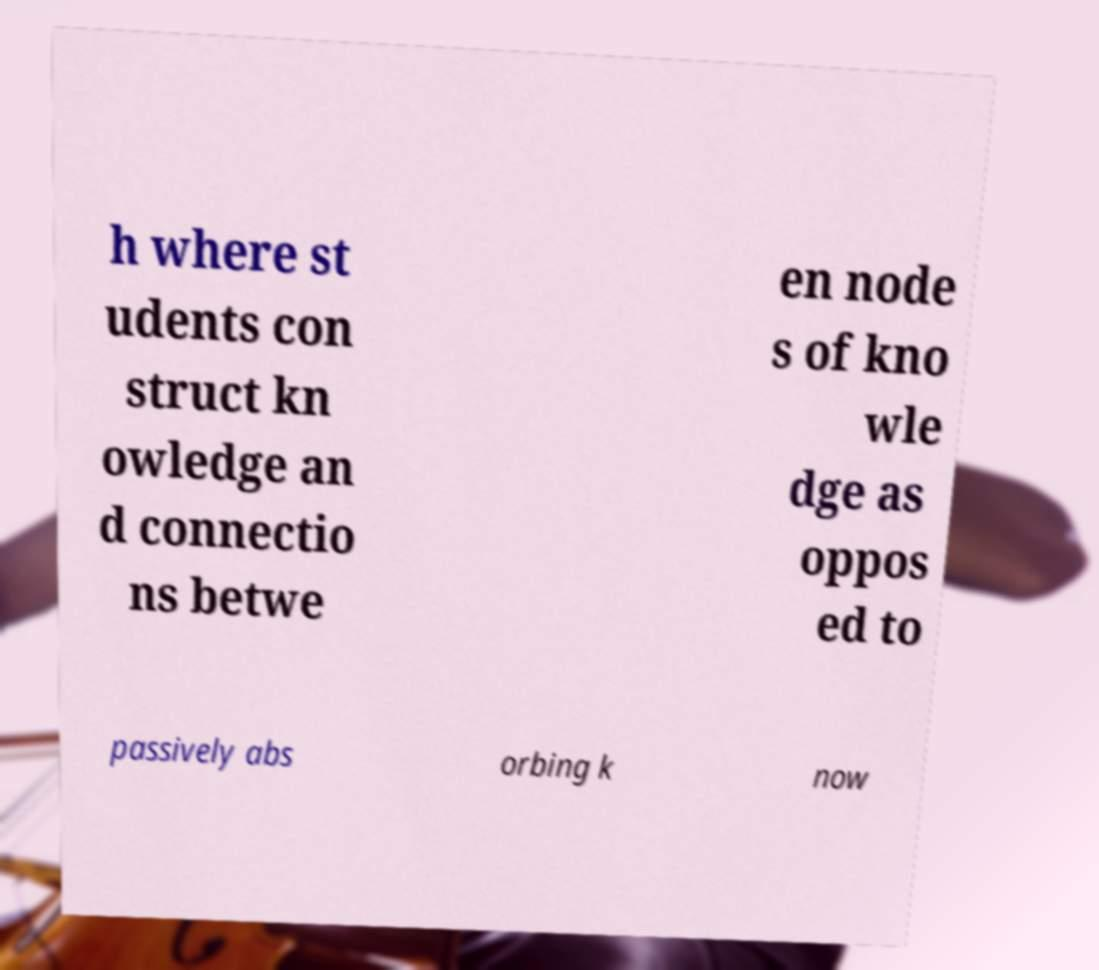Could you assist in decoding the text presented in this image and type it out clearly? h where st udents con struct kn owledge an d connectio ns betwe en node s of kno wle dge as oppos ed to passively abs orbing k now 